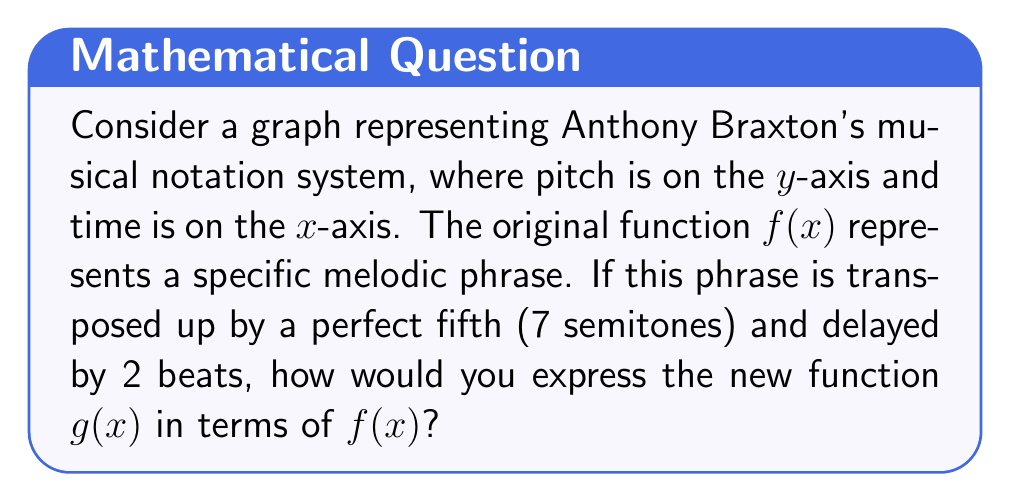Can you answer this question? Let's approach this step-by-step:

1) First, let's consider the vertical shift:
   - A perfect fifth is 7 semitones up
   - In function notation, this is represented by adding 7 to the output
   - So far, we have: $g(x) = f(x) + 7$

2) Now, let's consider the horizontal shift:
   - The phrase is delayed by 2 beats
   - In function notation, a delay is represented by subtracting from the input
   - This gives us: $g(x) = f(x - 2) + 7$

3) To understand why we subtract 2:
   - If we want the function to start 2 units later, we need to input $(x - 2)$ to get the same y-value that $f(x)$ would give for $x$
   - This effectively shifts the entire function 2 units to the right

4) The final function $g(x) = f(x - 2) + 7$ represents:
   - A horizontal shift of 2 units right: $f(x - 2)$
   - A vertical shift of 7 units up: $+ 7$

This transformation would visually represent Braxton's melodic phrase played 7 semitones higher and starting 2 beats later in the musical timeline.
Answer: $g(x) = f(x - 2) + 7$ 